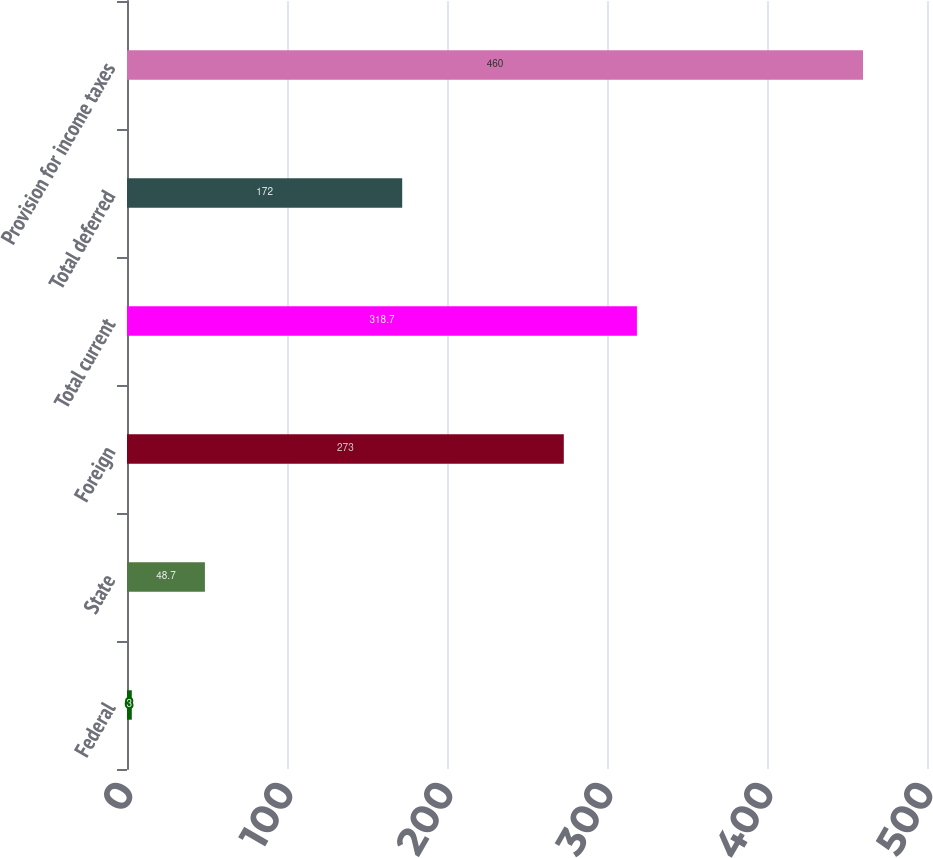Convert chart to OTSL. <chart><loc_0><loc_0><loc_500><loc_500><bar_chart><fcel>Federal<fcel>State<fcel>Foreign<fcel>Total current<fcel>Total deferred<fcel>Provision for income taxes<nl><fcel>3<fcel>48.7<fcel>273<fcel>318.7<fcel>172<fcel>460<nl></chart> 